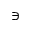<formula> <loc_0><loc_0><loc_500><loc_500>\ni</formula> 